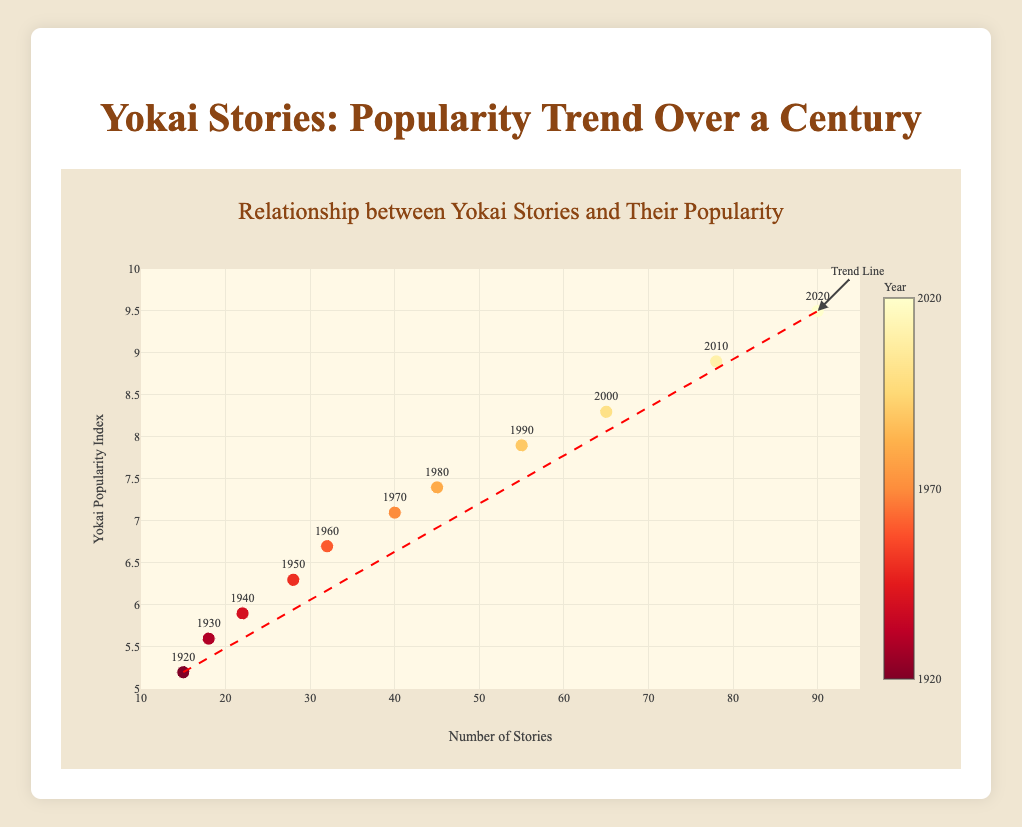What is the title of the plot? The title of the plot is positioned at the top and is clearly visible in a larger font. It conveys the main theme of the figure.
Answer: Yokai Stories: Popularity Trend Over a Century How many data points are there on the scatter plot? The number of points can be counted directly from the scatter plot where the markers are shown.
Answer: 11 What does the x-axis represent? In the scatter plot, the x-axis contains labels and units’ representation indicating what variable is plotted horizontally.
Answer: Number of Stories What does the y-axis represent? In the scatter plot, the y-axis contains labels and units’ representation indicating what variable is plotted vertically.
Answer: Yokai Popularity Index Which year had the highest number of stories featuring yokai? By identifying the data point furthest along the x-axis, you can find the year with the highest number of stories featuring yokai.
Answer: 2020 Between which years did the number of yokai stories increase the most? Calculate the differences in number of stories between consecutive years and identify the interval with the maximum change.
Answer: 2000 to 2010 What is the relationship between the number of stories and the yokai popularity index? Observe the overall trend of the data points and the trend line. An increase in one variable along with the other indicates a positive correlation.
Answer: Positive correlation Is there any data point that deviates significantly from the trend line? Examine the scatter plot to see if any data point is placed far from the trend line indicating it as an outlier.
Answer: No significant outlier Which year falls at the midpoint of the trend line in terms of number of stories, and what is the corresponding popularity index? The midpoint of the number of stories (x-axis) can be calculated using the trend line to find the corresponding y-axis value (popularity index). If x = (15+90)/2 = 52.5, then plug into the trend line equation y = 5.2 + [(9.5-5.2)/(90-15)]*(52.5-15).
Answer: 1955, approximately 6.6 By how much did the yokai popularity index increase from 1920 to 2020? Subtract the y-value in 1920 from the y-value in 2020 to compute the increase.
Answer: 4.3 